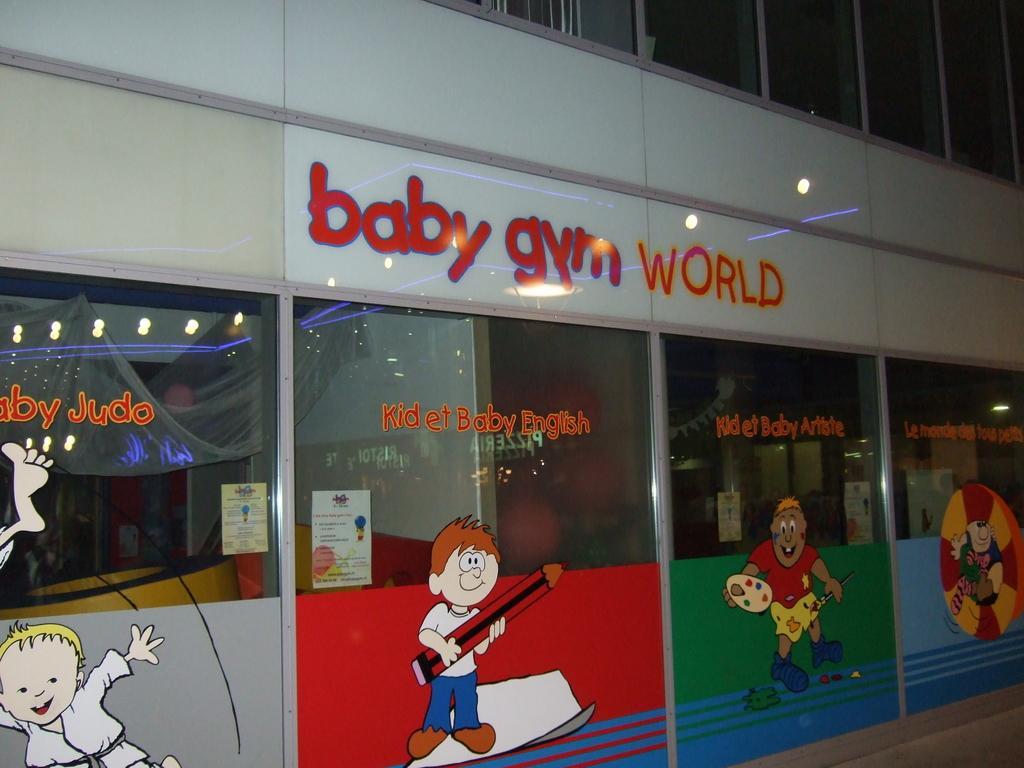Can you describe this image briefly? In the center of the image there is a building, glass, posters, cartoon images and some text on the glass. On the poster, we can see some text. Through glass, we can see one red color object, one solid structure, lights and a few other objects. 